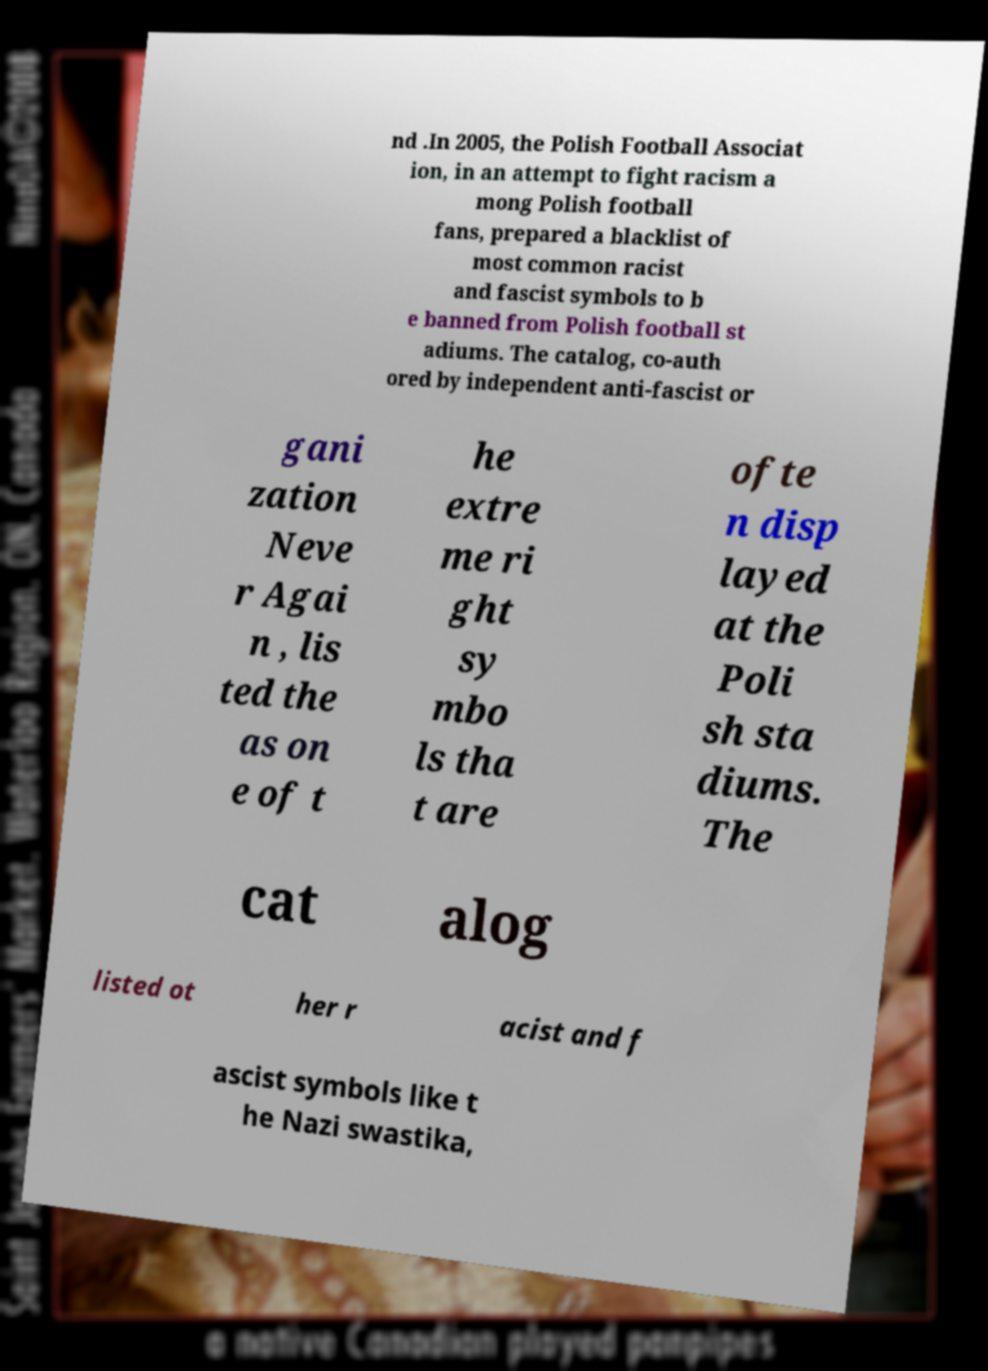Please read and relay the text visible in this image. What does it say? nd .In 2005, the Polish Football Associat ion, in an attempt to fight racism a mong Polish football fans, prepared a blacklist of most common racist and fascist symbols to b e banned from Polish football st adiums. The catalog, co-auth ored by independent anti-fascist or gani zation Neve r Agai n , lis ted the as on e of t he extre me ri ght sy mbo ls tha t are ofte n disp layed at the Poli sh sta diums. The cat alog listed ot her r acist and f ascist symbols like t he Nazi swastika, 